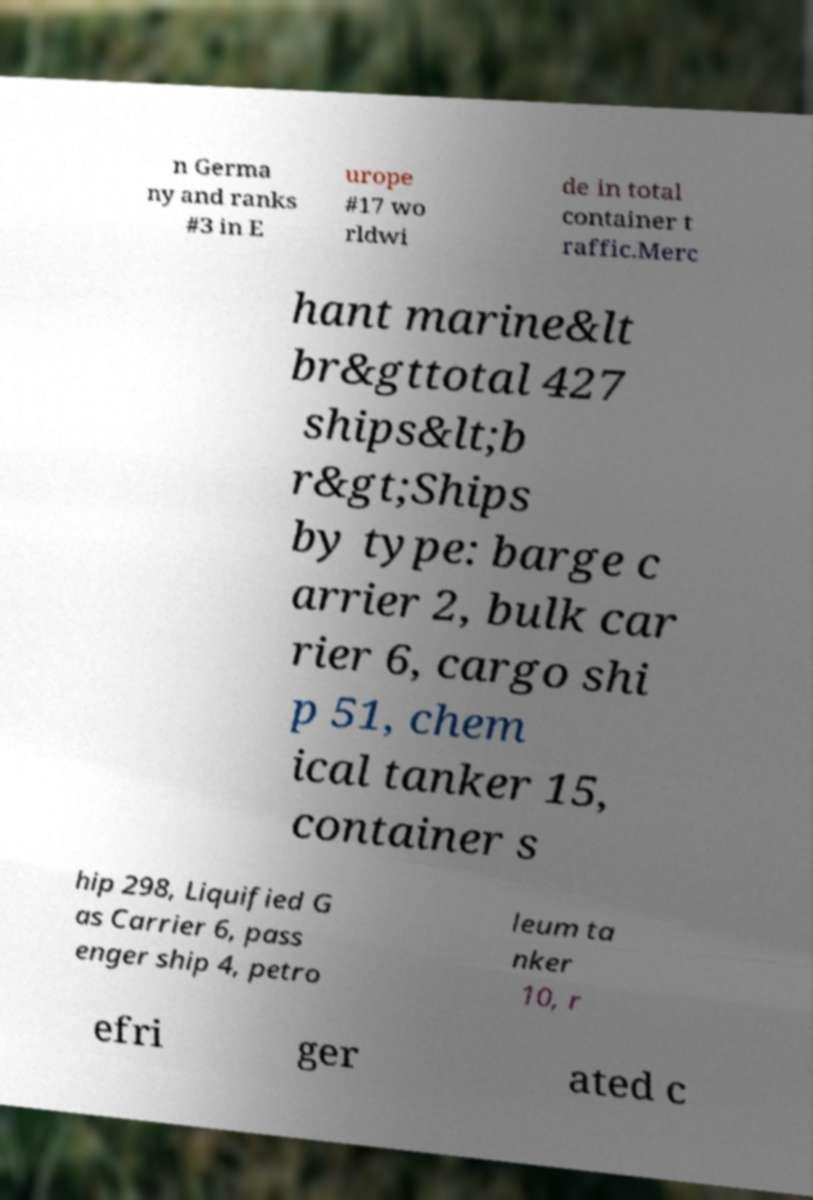There's text embedded in this image that I need extracted. Can you transcribe it verbatim? n Germa ny and ranks #3 in E urope #17 wo rldwi de in total container t raffic.Merc hant marine&lt br&gttotal 427 ships&lt;b r&gt;Ships by type: barge c arrier 2, bulk car rier 6, cargo shi p 51, chem ical tanker 15, container s hip 298, Liquified G as Carrier 6, pass enger ship 4, petro leum ta nker 10, r efri ger ated c 